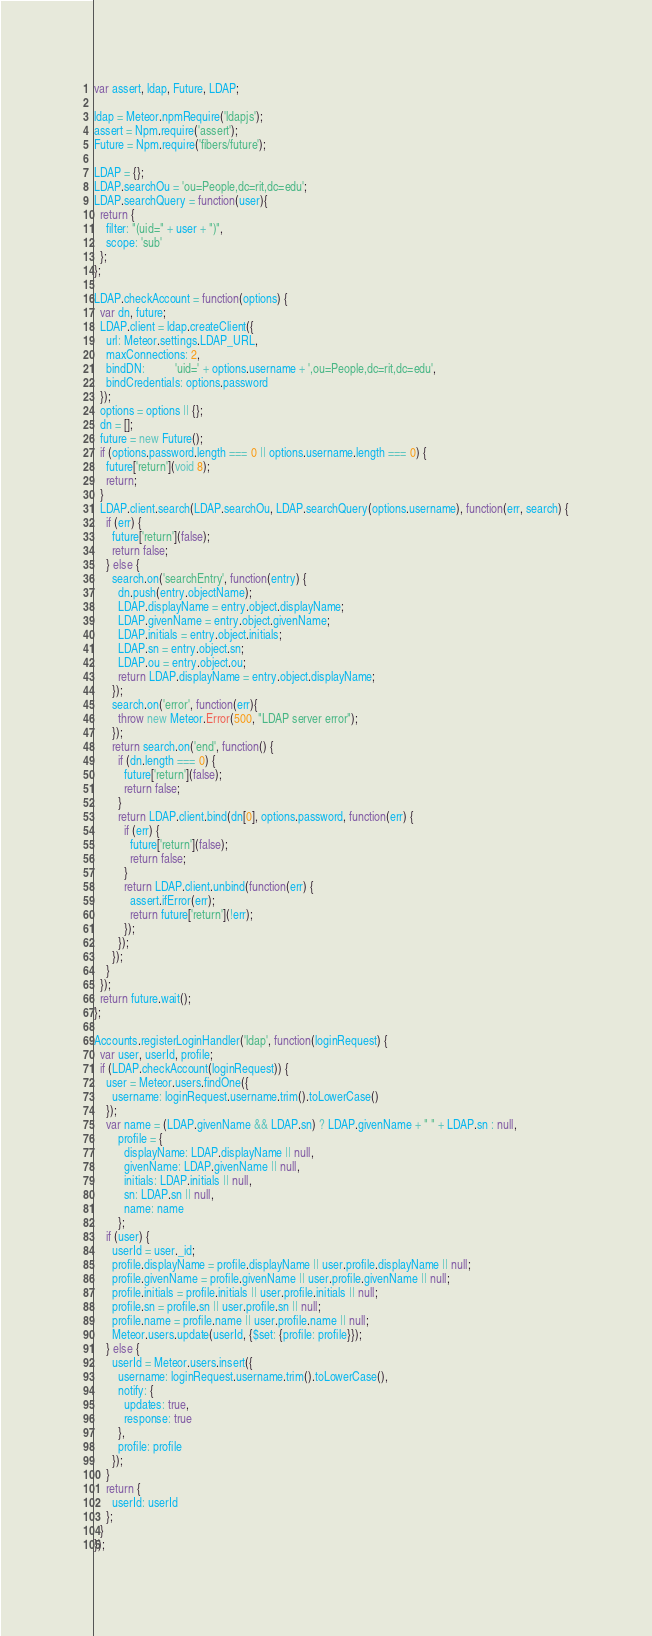Convert code to text. <code><loc_0><loc_0><loc_500><loc_500><_JavaScript_>var assert, ldap, Future, LDAP;

ldap = Meteor.npmRequire('ldapjs');
assert = Npm.require('assert');
Future = Npm.require('fibers/future');

LDAP = {};
LDAP.searchOu = 'ou=People,dc=rit,dc=edu';
LDAP.searchQuery = function(user){
  return {
    filter: "(uid=" + user + ")",
    scope: 'sub'
  };
};

LDAP.checkAccount = function(options) {
  var dn, future;
  LDAP.client = ldap.createClient({
    url: Meteor.settings.LDAP_URL,
    maxConnections: 2,
    bindDN:          'uid=' + options.username + ',ou=People,dc=rit,dc=edu',
    bindCredentials: options.password
  });
  options = options || {};
  dn = [];
  future = new Future();
  if (options.password.length === 0 || options.username.length === 0) {
    future['return'](void 8);
    return;
  }
  LDAP.client.search(LDAP.searchOu, LDAP.searchQuery(options.username), function(err, search) {
    if (err) {
      future['return'](false);
      return false;
    } else {
      search.on('searchEntry', function(entry) {
        dn.push(entry.objectName);
        LDAP.displayName = entry.object.displayName;
        LDAP.givenName = entry.object.givenName;
        LDAP.initials = entry.object.initials;
        LDAP.sn = entry.object.sn;
        LDAP.ou = entry.object.ou;
        return LDAP.displayName = entry.object.displayName;
      });
      search.on('error', function(err){
        throw new Meteor.Error(500, "LDAP server error");
      });
      return search.on('end', function() {
        if (dn.length === 0) {
          future['return'](false);
          return false;
        }
        return LDAP.client.bind(dn[0], options.password, function(err) {
          if (err) {
            future['return'](false);
            return false;
          }
          return LDAP.client.unbind(function(err) {
            assert.ifError(err);
            return future['return'](!err);
          });
        });
      });
    }
  });
  return future.wait();
};

Accounts.registerLoginHandler('ldap', function(loginRequest) {
  var user, userId, profile;
  if (LDAP.checkAccount(loginRequest)) {
    user = Meteor.users.findOne({
      username: loginRequest.username.trim().toLowerCase()
    });
    var name = (LDAP.givenName && LDAP.sn) ? LDAP.givenName + " " + LDAP.sn : null,
        profile = {
          displayName: LDAP.displayName || null,
          givenName: LDAP.givenName || null,
          initials: LDAP.initials || null,
          sn: LDAP.sn || null,
          name: name
        };
    if (user) {
      userId = user._id;
      profile.displayName = profile.displayName || user.profile.displayName || null;
      profile.givenName = profile.givenName || user.profile.givenName || null;
      profile.initials = profile.initials || user.profile.initials || null;
      profile.sn = profile.sn || user.profile.sn || null;
      profile.name = profile.name || user.profile.name || null;
      Meteor.users.update(userId, {$set: {profile: profile}});
    } else {
      userId = Meteor.users.insert({
        username: loginRequest.username.trim().toLowerCase(),
        notify: {
          updates: true,
          response: true
        },
        profile: profile
      });
    }
    return {
      userId: userId
    };
  }
});
</code> 